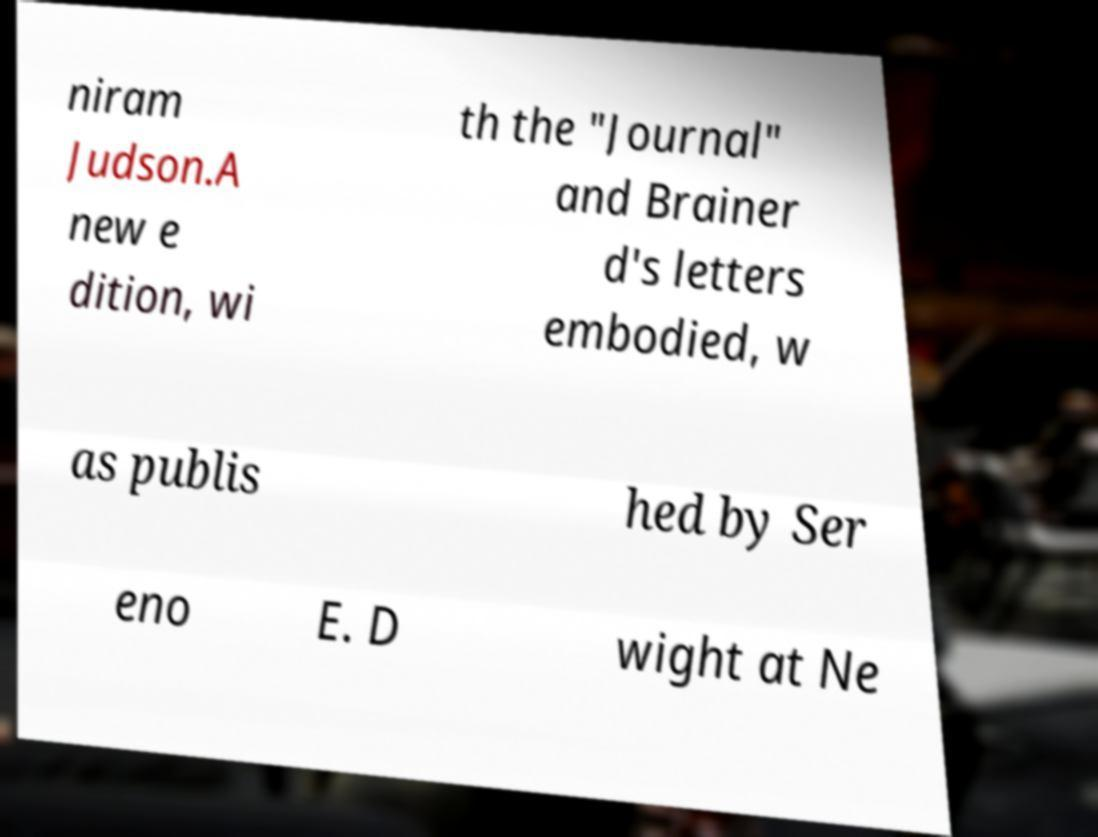Could you assist in decoding the text presented in this image and type it out clearly? niram Judson.A new e dition, wi th the "Journal" and Brainer d's letters embodied, w as publis hed by Ser eno E. D wight at Ne 